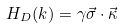<formula> <loc_0><loc_0><loc_500><loc_500>H _ { D } ( k ) = \gamma \vec { \sigma } \cdot \vec { \kappa }</formula> 